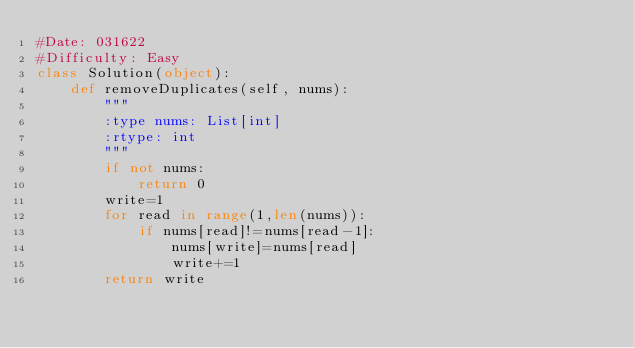Convert code to text. <code><loc_0><loc_0><loc_500><loc_500><_Python_>#Date: 031622
#Difficulty: Easy
class Solution(object):
    def removeDuplicates(self, nums):
        """
        :type nums: List[int]
        :rtype: int
        """
        if not nums:
            return 0
        write=1
        for read in range(1,len(nums)):
            if nums[read]!=nums[read-1]:
                nums[write]=nums[read]
                write+=1
        return write
</code> 